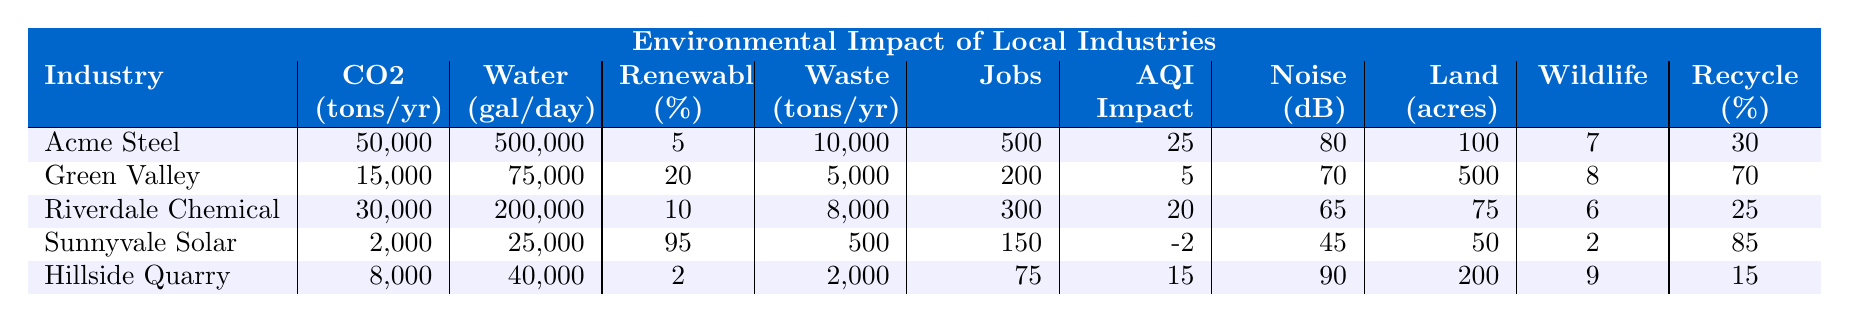What is the CO2 emission of the Acme Steel Manufacturing industry? The table states that Acme Steel Manufacturing has annual CO2 emissions of 50,000 tons.
Answer: 50,000 tons Which industry has the lowest water consumption per day? The table shows Sunnyvale Solar Panel Factory with water consumption of 25,000 gallons per day, which is the lowest among the listed industries.
Answer: Sunnyvale Solar Panel Factory What is the total number of local jobs created by all industries combined? Summing the local jobs created: 500 (Acme) + 200 (Green Valley) + 300 (Riverdale) + 150 (Sunnyvale) + 75 (Hillside) results in a total of 1225 local jobs.
Answer: 1,225 Is the recycling rate of Green Valley Lumber higher than that of Hillside Quarry? The recycling rate of Green Valley Lumber is 70%, while that of Hillside Quarry is 15%, making Green Valley's recycling rate higher.
Answer: Yes What is the industry with the highest renewable energy usage percentage? According to the table, Sunnyvale Solar Panel Factory has the highest renewable energy usage at 95%.
Answer: Sunnyvale Solar Panel Factory Calculate the average water consumption across all industries. The total water consumption is 500,000 + 75,000 + 200,000 + 25,000 + 40,000 = 840,000 gallons. Dividing by the number of industries (5) gives an average of 168,000 gallons per day.
Answer: 168,000 gallons Which industry impacts the air quality index negatively? The Sunnyvale Solar Panel Factory has an AQI impact of -2, indicating a negative effect on air quality.
Answer: Sunnyvale Solar Panel Factory What is the difference in waste produced per year between Acme Steel and Sunnyvale Solar Panel Factory? Acme Steel produces 10,000 tons of waste, while Sunnyvale produces 500 tons. The difference is 10,000 - 500 = 9,500 tons.
Answer: 9,500 tons How many industries have a noise pollution level above 75 decibels? The table shows that Acme Steel (80 dB), Hillside Quarry (90 dB), and one other industry exceed 75 dB, making a total of three industries.
Answer: 3 industries Is the wildlife habitat disruption score for Hillside Quarry higher than that for Riverdale Chemical Plant? Hillside Quarry has a disruption score of 9, while Riverdale Chemical has 6, indicating Hillside has a higher score.
Answer: Yes 